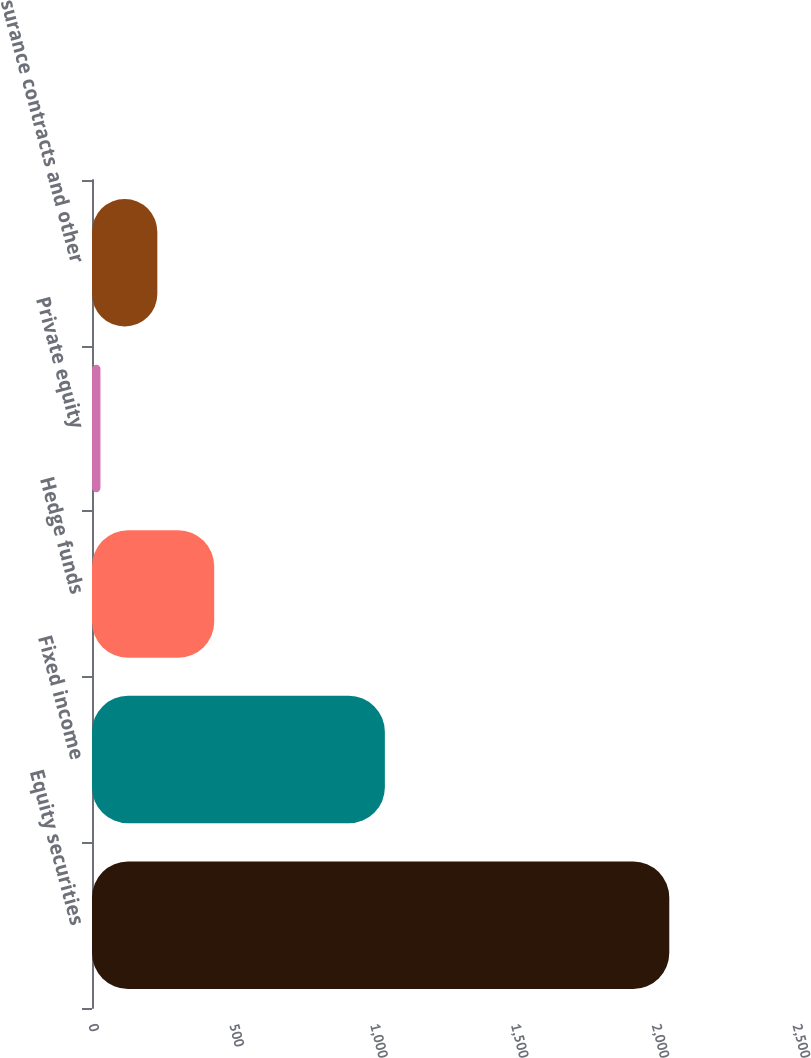<chart> <loc_0><loc_0><loc_500><loc_500><bar_chart><fcel>Equity securities<fcel>Fixed income<fcel>Hedge funds<fcel>Private equity<fcel>Insurance contracts and other<nl><fcel>2050<fcel>1040<fcel>434<fcel>30<fcel>232<nl></chart> 